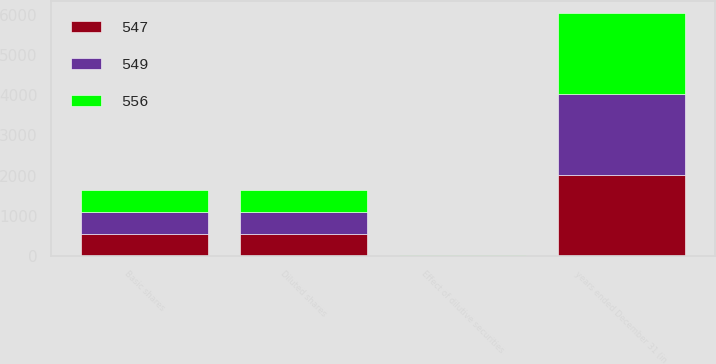<chart> <loc_0><loc_0><loc_500><loc_500><stacked_bar_chart><ecel><fcel>years ended December 31 (in<fcel>Basic shares<fcel>Effect of dilutive securities<fcel>Diluted shares<nl><fcel>556<fcel>2014<fcel>542<fcel>5<fcel>547<nl><fcel>547<fcel>2013<fcel>543<fcel>6<fcel>549<nl><fcel>549<fcel>2012<fcel>551<fcel>5<fcel>556<nl></chart> 